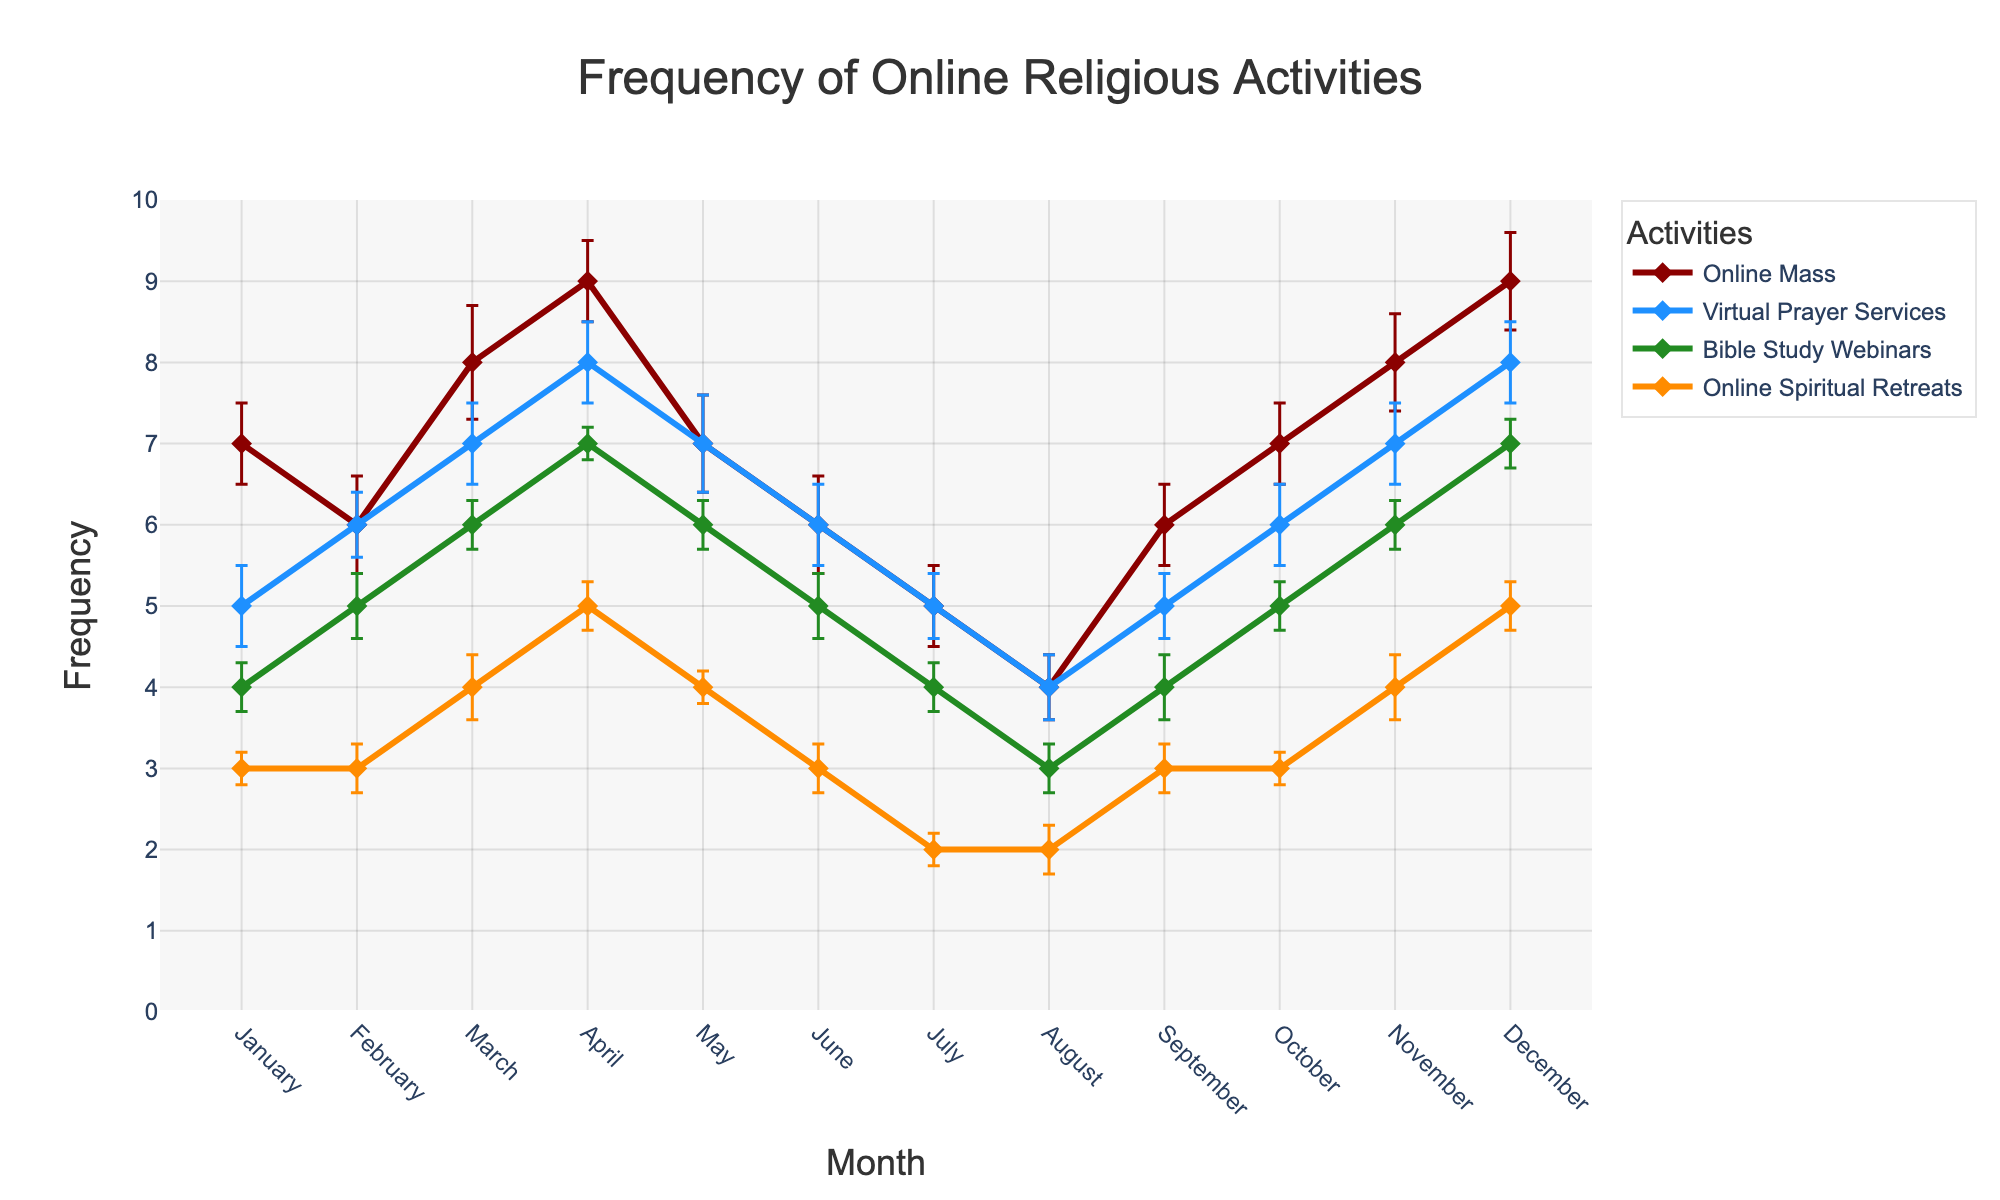what is the title of the plot? The title is typically located at the top of the plot and prominently displayed. It summarizes what the plot represents using natural language. In this case, the title reads 'Frequency of Online Religious Activities'.
Answer: Frequency of Online Religious Activities Which activity had the highest frequency in April? To answer this, we look at the data points for April and compare the y-values of each activity. The highest frequency is for 'Online Mass', which is at 9.
Answer: Online Mass How does the frequency of Virtual Prayer Services change from January to December? To determine this, we look at the line representing Virtual Prayer Services and observe how it varies month by month. It starts at 5 in January, increases to 8 in April, drops to 4 in August, and ends at 8 in December.
Answer: Increases then decreases, before again increasing What's the average frequency of Bible Study Webinars over the year? Calculating the average involves summing up the monthly frequencies and dividing by the number of months. Adding up the values (4, 5, 6, 7, 6, 5, 4, 3, 4, 5, 6, 7) and dividing by 12 results in 5.
Answer: 5 Which month shows the least participation in Online Spiritual Retreats? To identify this, look for the month with the lowest y-value on the Online Spiritual Retreats line. The lowest value is 2, observed in July and August.
Answer: July and August Compare the highest and lowest frequencies of Online Mass throughout the year. What is the difference between them? The highest frequency of Online Mass is 9 (in April and December), and the lowest is 4 (in August). The difference is calculated by subtracting the smallest value from the largest: 9 - 4 = 5.
Answer: 5 During which months did the frequency of Virtual Prayer Services stay constant, and what was that frequency? By observing the Virtual Prayer Services line, it remains constant at 7 from March to May.
Answer: March to May at 7 Is there any month when all activities had the same frequency? We need to find a month where the y-values of all activities intersect or come close together. There is no such month in the given data where all activities shared the same frequency.
Answer: No What is the overall trend in the frequency of Online Mass from January to December, including the error bars? The overall trend can be identified by observing the line for Online Mass. It shows an increasing trend from January (7) to April (9), decreases to August (4), and again increases towards December (9). Error bars indicate variability but do not change this trend.
Answer: Increasing then decreasing, then increasing 